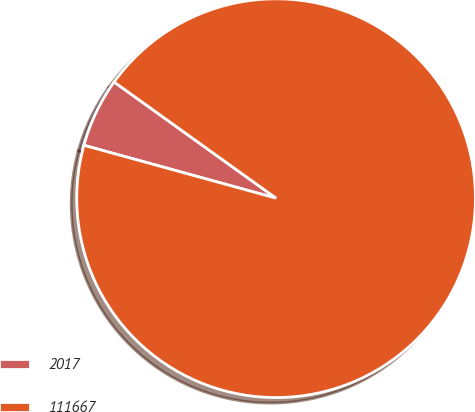<chart> <loc_0><loc_0><loc_500><loc_500><pie_chart><fcel>2017<fcel>111667<nl><fcel>5.63%<fcel>94.37%<nl></chart> 